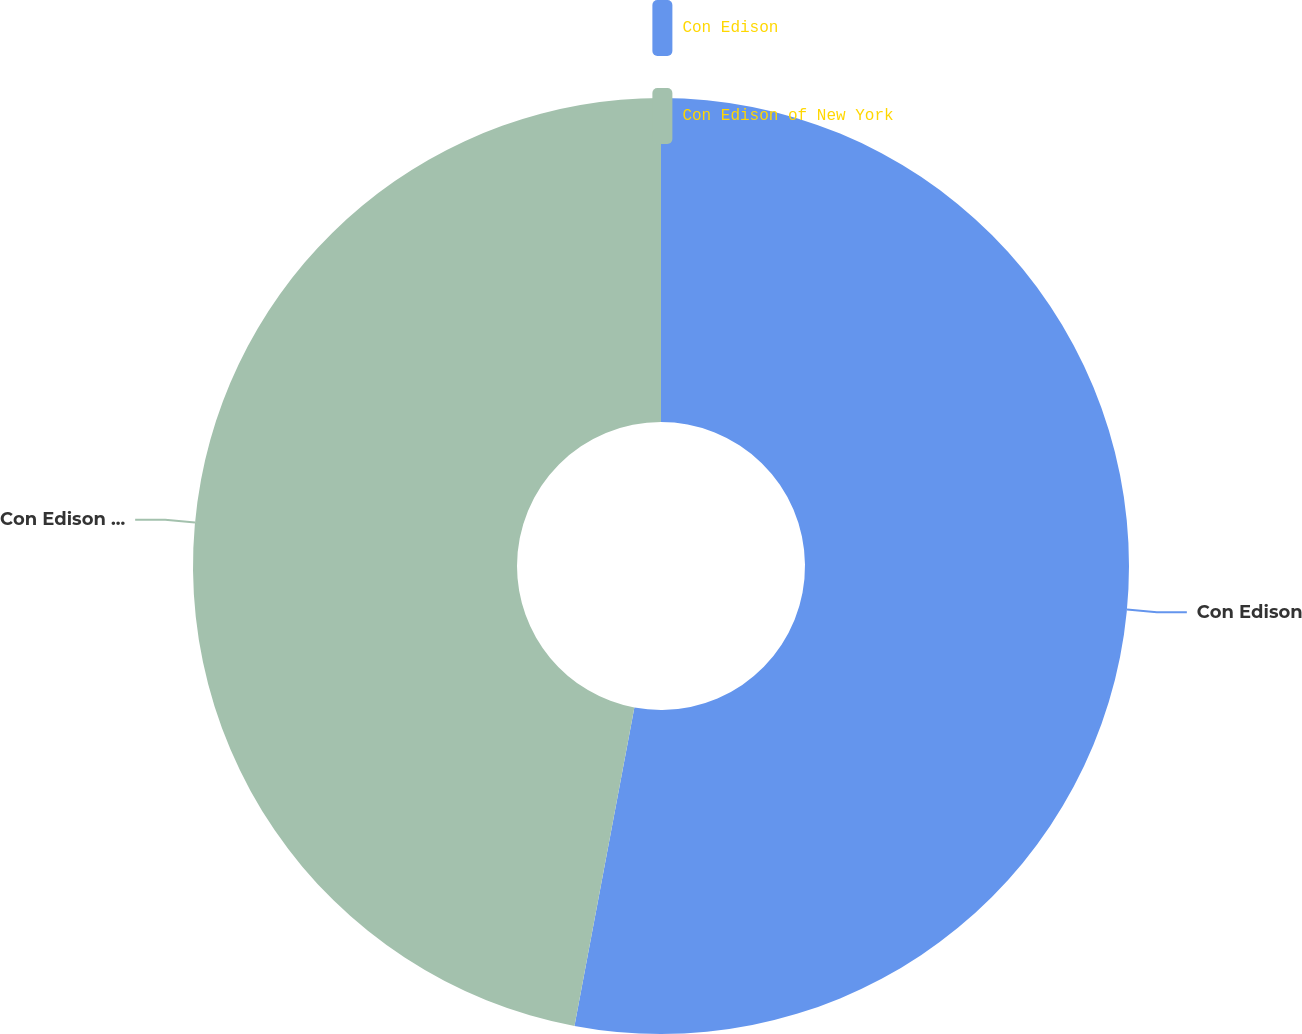<chart> <loc_0><loc_0><loc_500><loc_500><pie_chart><fcel>Con Edison<fcel>Con Edison of New York<nl><fcel>52.96%<fcel>47.04%<nl></chart> 